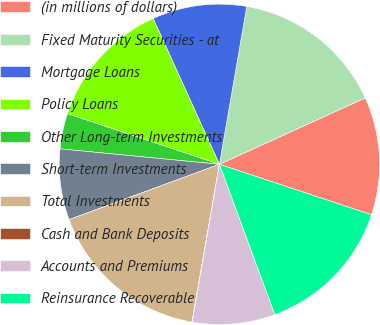Convert chart to OTSL. <chart><loc_0><loc_0><loc_500><loc_500><pie_chart><fcel>(in millions of dollars)<fcel>Fixed Maturity Securities - at<fcel>Mortgage Loans<fcel>Policy Loans<fcel>Other Long-term Investments<fcel>Short-term Investments<fcel>Total Investments<fcel>Cash and Bank Deposits<fcel>Accounts and Premiums<fcel>Reinsurance Recoverable<nl><fcel>11.9%<fcel>15.47%<fcel>9.52%<fcel>13.09%<fcel>3.58%<fcel>7.15%<fcel>16.65%<fcel>0.02%<fcel>8.34%<fcel>14.28%<nl></chart> 